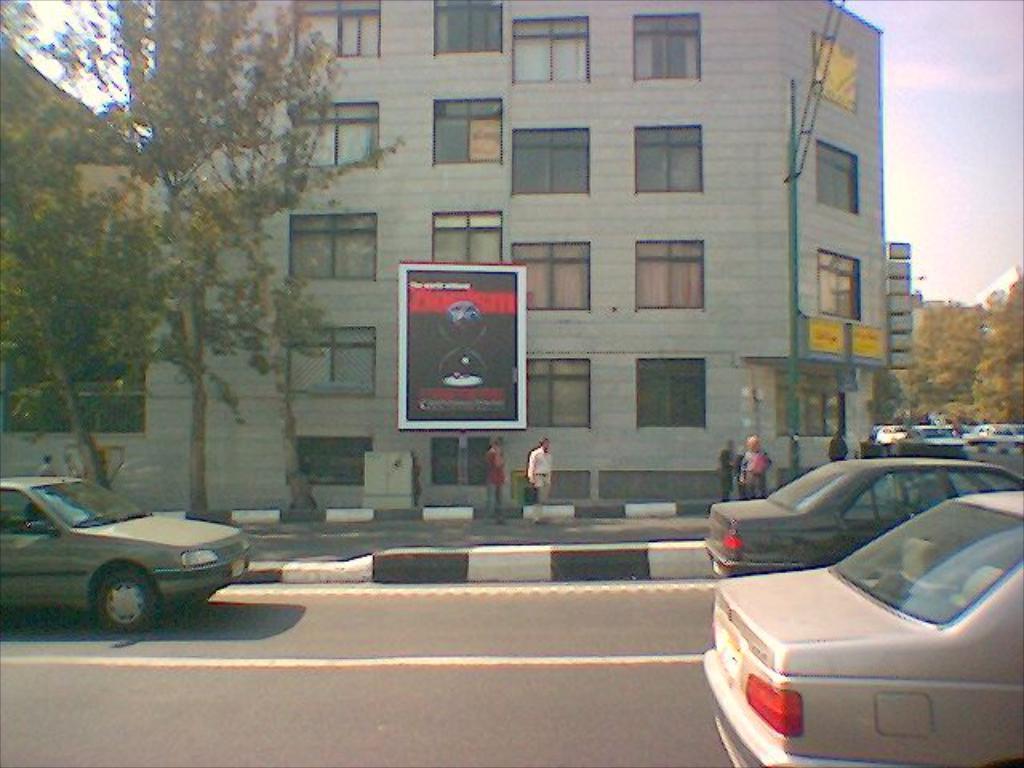Could you give a brief overview of what you see in this image? In this image we can see the vehicles on the road and there are people standing on the ground. We can see the board near the building. And there are trees and the sky in the background. 